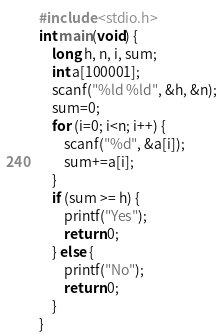Convert code to text. <code><loc_0><loc_0><loc_500><loc_500><_C_>#include <stdio.h>
int main(void) {
    long h, n, i, sum;
    int a[100001];
    scanf("%ld %ld", &h, &n);
    sum=0;
    for (i=0; i<n; i++) {
        scanf("%d", &a[i]);
        sum+=a[i];
    }
    if (sum >= h) {
        printf("Yes");
        return 0;
    } else {
        printf("No");
        return 0;
    }
}</code> 